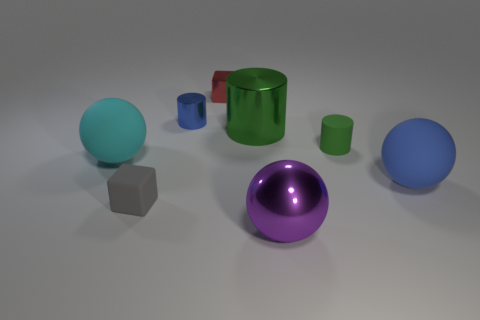There is another metallic thing that is the same shape as the blue shiny object; what is its size?
Provide a short and direct response. Large. How many green objects are there?
Offer a very short reply. 2. Is the shape of the cyan object the same as the large matte thing that is right of the small gray matte block?
Your answer should be very brief. Yes. There is a blue thing behind the big blue ball; how big is it?
Ensure brevity in your answer.  Small. What is the material of the large blue ball?
Keep it short and to the point. Rubber. Does the blue thing that is to the right of the small shiny cube have the same shape as the small green object?
Your answer should be compact. No. What is the size of the thing that is the same color as the rubber cylinder?
Your answer should be compact. Large. Are there any other metal things of the same size as the red thing?
Offer a terse response. Yes. There is a blue thing in front of the rubber ball to the left of the big purple metallic ball; are there any red blocks that are in front of it?
Offer a very short reply. No. There is a big metal ball; is it the same color as the big thing behind the big cyan rubber thing?
Offer a terse response. No. 